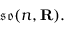<formula> <loc_0><loc_0><loc_500><loc_500>{ \mathfrak { s o } } ( n , R ) .</formula> 